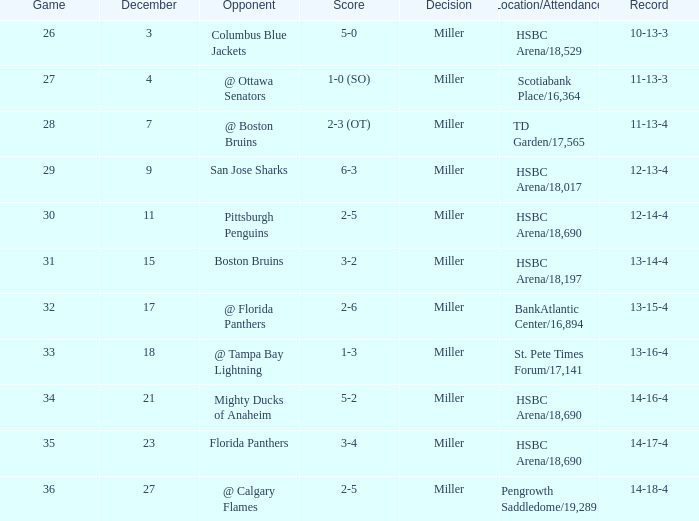Name the opponent for record 10-13-3 Columbus Blue Jackets. 